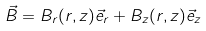<formula> <loc_0><loc_0><loc_500><loc_500>\vec { B } = B _ { r } ( r , z ) \vec { e } _ { r } + B _ { z } ( r , z ) \vec { e } _ { z }</formula> 